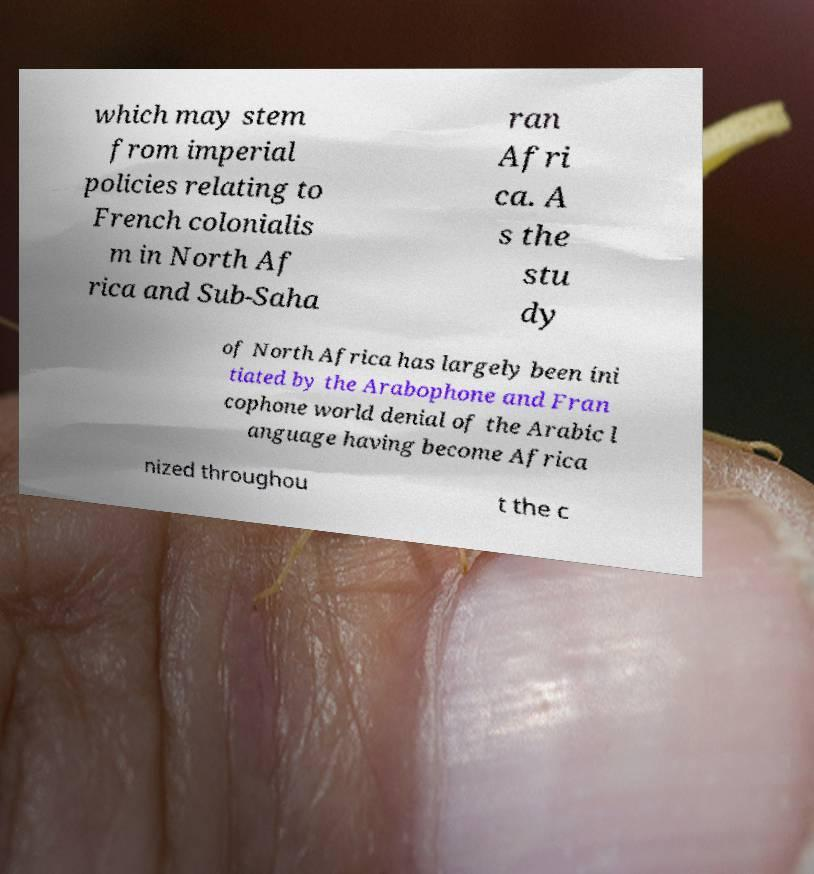Please identify and transcribe the text found in this image. which may stem from imperial policies relating to French colonialis m in North Af rica and Sub-Saha ran Afri ca. A s the stu dy of North Africa has largely been ini tiated by the Arabophone and Fran cophone world denial of the Arabic l anguage having become Africa nized throughou t the c 